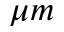<formula> <loc_0><loc_0><loc_500><loc_500>\mu m</formula> 